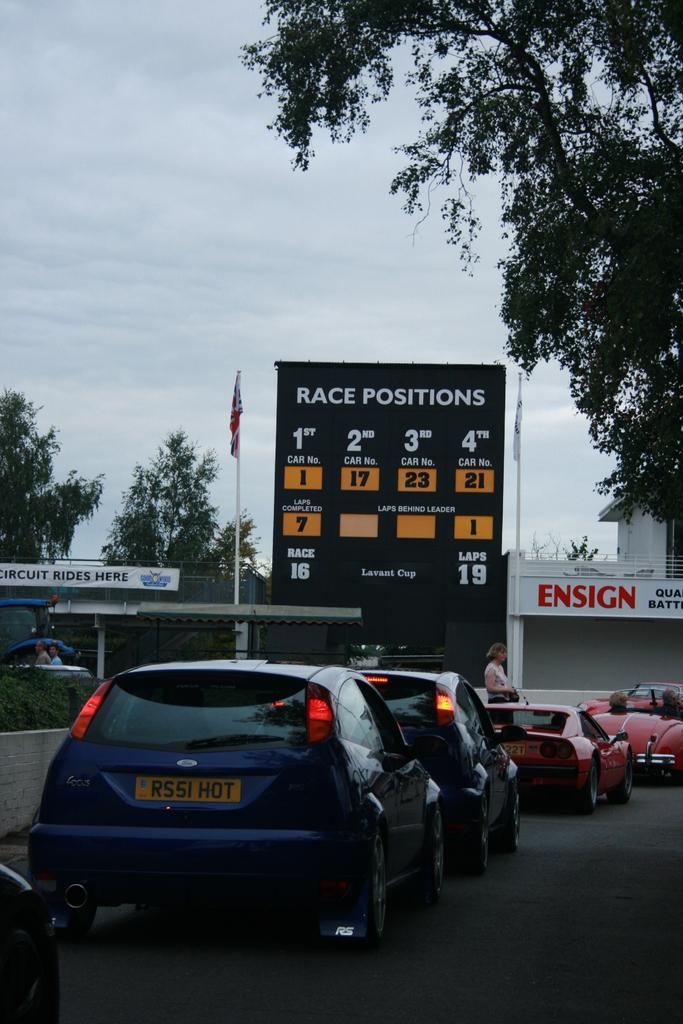Describe this image in one or two sentences. In this image we can see cars on the road and there are people. In the background there is a board and a flag. We can see trees, buildings and sky. 